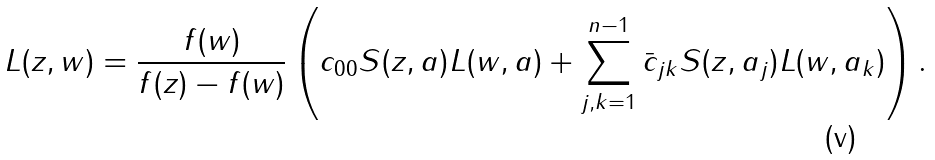Convert formula to latex. <formula><loc_0><loc_0><loc_500><loc_500>L ( z , w ) = \frac { f ( w ) } { f ( z ) - f ( w ) } \left ( c _ { 0 0 } S ( z , a ) L ( w , a ) + \sum _ { j , k = 1 } ^ { n - 1 } \bar { c } _ { j k } S ( z , a _ { j } ) L ( w , a _ { k } ) \right ) .</formula> 